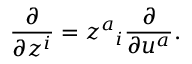Convert formula to latex. <formula><loc_0><loc_0><loc_500><loc_500>\frac { \partial } { \partial z ^ { i } } = z ^ { a _ { i } \frac { \partial } { \partial u ^ { a } } .</formula> 